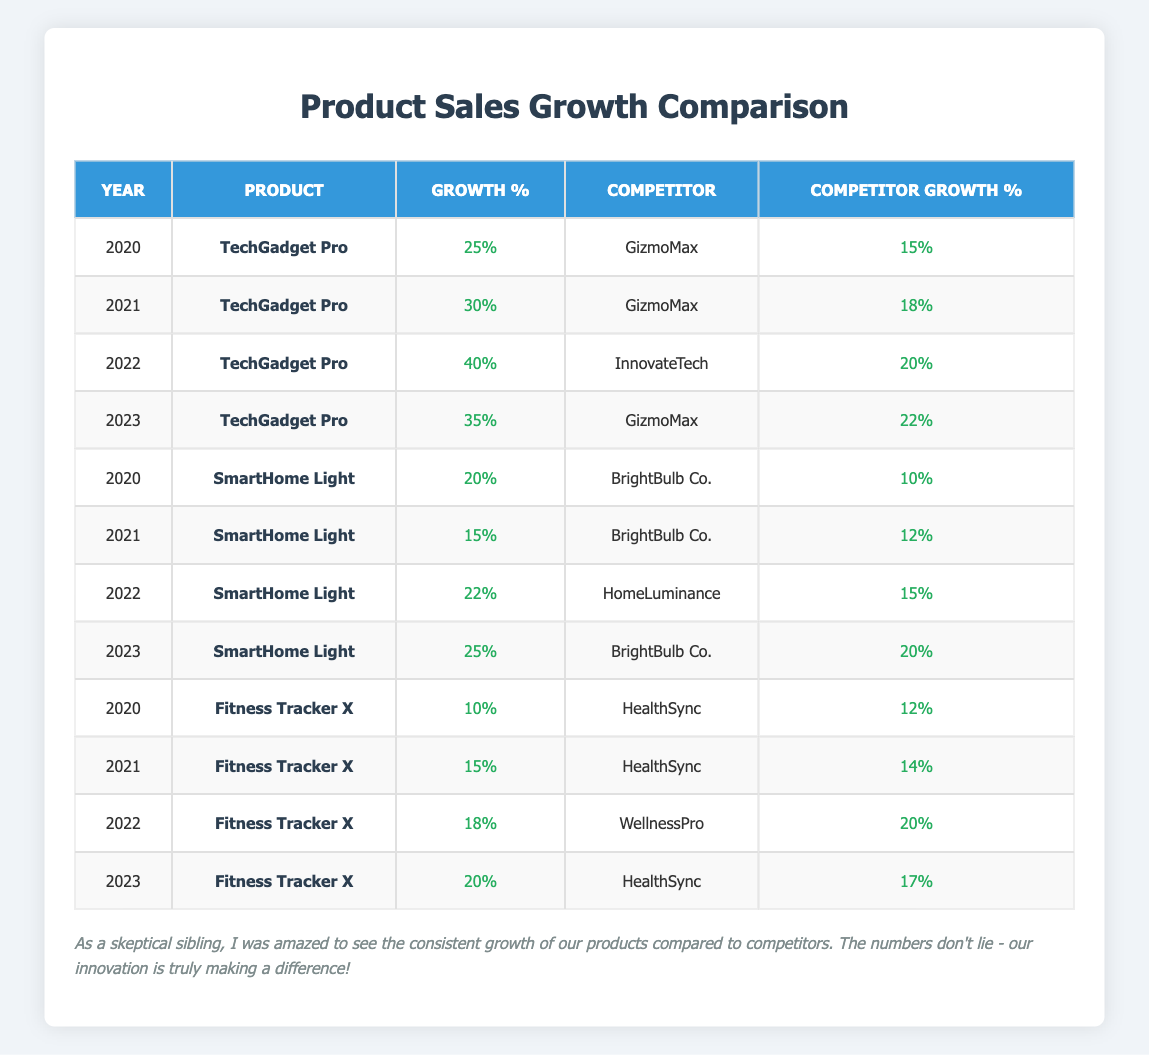What was TechGadget Pro's growth percentage in 2021? The table shows that in 2021, the growth percentage for TechGadget Pro is listed as 30%.
Answer: 30% Which product had the highest growth percentage in 2022? In 2022, TechGadget Pro had a growth percentage of 40%, which is higher than SmartHome Light's 22% and Fitness Tracker X's 18%. Therefore, TechGadget Pro had the highest growth percentage.
Answer: TechGadget Pro What is the difference in growth percentage between SmartHome Light and BrightBulb Co. in 2023? In 2023, SmartHome Light had a growth percentage of 25% while BrightBulb Co. had 20%. The difference is 25% - 20% = 5%.
Answer: 5% Did TechGadget Pro ever have a lower growth percentage than its competitors? By examining the table, TechGadget Pro had a higher growth percentage than GizmoMax in 2020, 2021, and 2023, and higher than InnovateTech in 2022. Therefore, it never had a lower percentage than its competitors.
Answer: No What was the average growth percentage of Fitness Tracker X over the four years? The growth percentages for Fitness Tracker X are 10%, 15%, 18%, and 20% over the years 2020 to 2023. To find the average, sum these values (10 + 15 + 18 + 20 = 63) and divide by the number of years (4). So, 63/4 = 15.75%.
Answer: 15.75% 